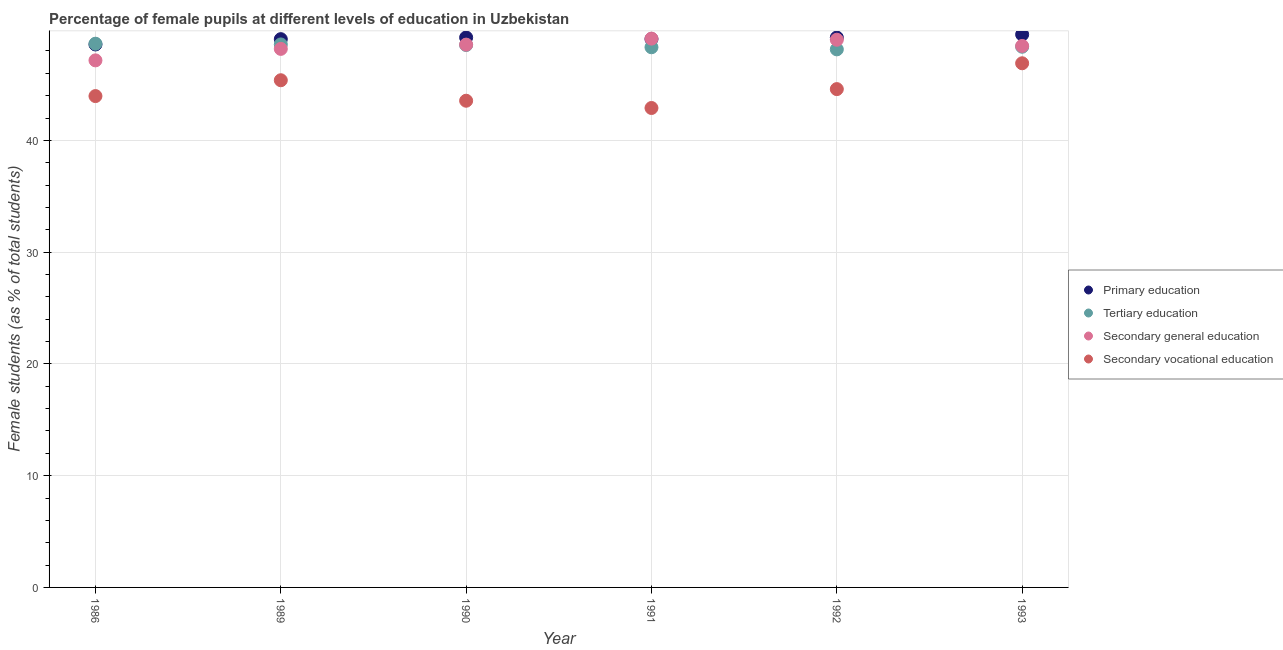What is the percentage of female students in secondary vocational education in 1989?
Provide a succinct answer. 45.38. Across all years, what is the maximum percentage of female students in secondary education?
Keep it short and to the point. 49.1. Across all years, what is the minimum percentage of female students in secondary education?
Provide a short and direct response. 47.16. In which year was the percentage of female students in primary education minimum?
Your answer should be compact. 1986. What is the total percentage of female students in secondary education in the graph?
Ensure brevity in your answer.  290.46. What is the difference between the percentage of female students in secondary education in 1989 and that in 1990?
Ensure brevity in your answer.  -0.38. What is the difference between the percentage of female students in primary education in 1992 and the percentage of female students in secondary education in 1991?
Make the answer very short. 0.1. What is the average percentage of female students in secondary education per year?
Make the answer very short. 48.41. In the year 1990, what is the difference between the percentage of female students in secondary vocational education and percentage of female students in tertiary education?
Ensure brevity in your answer.  -4.99. What is the ratio of the percentage of female students in secondary vocational education in 1989 to that in 1990?
Ensure brevity in your answer.  1.04. Is the percentage of female students in secondary education in 1992 less than that in 1993?
Your response must be concise. No. Is the difference between the percentage of female students in secondary education in 1989 and 1990 greater than the difference between the percentage of female students in secondary vocational education in 1989 and 1990?
Keep it short and to the point. No. What is the difference between the highest and the second highest percentage of female students in secondary vocational education?
Offer a terse response. 1.52. What is the difference between the highest and the lowest percentage of female students in secondary vocational education?
Provide a short and direct response. 4. In how many years, is the percentage of female students in secondary vocational education greater than the average percentage of female students in secondary vocational education taken over all years?
Provide a short and direct response. 3. Is the sum of the percentage of female students in secondary vocational education in 1990 and 1991 greater than the maximum percentage of female students in primary education across all years?
Make the answer very short. Yes. Is it the case that in every year, the sum of the percentage of female students in primary education and percentage of female students in tertiary education is greater than the percentage of female students in secondary education?
Keep it short and to the point. Yes. Is the percentage of female students in tertiary education strictly greater than the percentage of female students in secondary vocational education over the years?
Provide a short and direct response. Yes. Is the percentage of female students in primary education strictly less than the percentage of female students in secondary vocational education over the years?
Give a very brief answer. No. How many dotlines are there?
Provide a short and direct response. 4. Does the graph contain any zero values?
Ensure brevity in your answer.  No. How many legend labels are there?
Make the answer very short. 4. What is the title of the graph?
Provide a short and direct response. Percentage of female pupils at different levels of education in Uzbekistan. What is the label or title of the Y-axis?
Provide a succinct answer. Female students (as % of total students). What is the Female students (as % of total students) in Primary education in 1986?
Provide a succinct answer. 48.58. What is the Female students (as % of total students) in Tertiary education in 1986?
Keep it short and to the point. 48.65. What is the Female students (as % of total students) in Secondary general education in 1986?
Keep it short and to the point. 47.16. What is the Female students (as % of total students) of Secondary vocational education in 1986?
Keep it short and to the point. 43.96. What is the Female students (as % of total students) of Primary education in 1989?
Your answer should be compact. 49.06. What is the Female students (as % of total students) of Tertiary education in 1989?
Your response must be concise. 48.58. What is the Female students (as % of total students) of Secondary general education in 1989?
Provide a succinct answer. 48.18. What is the Female students (as % of total students) in Secondary vocational education in 1989?
Your response must be concise. 45.38. What is the Female students (as % of total students) of Primary education in 1990?
Your response must be concise. 49.2. What is the Female students (as % of total students) of Tertiary education in 1990?
Ensure brevity in your answer.  48.53. What is the Female students (as % of total students) of Secondary general education in 1990?
Make the answer very short. 48.57. What is the Female students (as % of total students) in Secondary vocational education in 1990?
Ensure brevity in your answer.  43.55. What is the Female students (as % of total students) in Primary education in 1991?
Offer a terse response. 49.06. What is the Female students (as % of total students) in Tertiary education in 1991?
Provide a succinct answer. 48.33. What is the Female students (as % of total students) in Secondary general education in 1991?
Offer a very short reply. 49.1. What is the Female students (as % of total students) in Secondary vocational education in 1991?
Provide a succinct answer. 42.9. What is the Female students (as % of total students) of Primary education in 1992?
Keep it short and to the point. 49.2. What is the Female students (as % of total students) of Tertiary education in 1992?
Provide a succinct answer. 48.14. What is the Female students (as % of total students) of Secondary general education in 1992?
Give a very brief answer. 49. What is the Female students (as % of total students) of Secondary vocational education in 1992?
Give a very brief answer. 44.59. What is the Female students (as % of total students) of Primary education in 1993?
Your response must be concise. 49.47. What is the Female students (as % of total students) in Tertiary education in 1993?
Make the answer very short. 48.38. What is the Female students (as % of total students) of Secondary general education in 1993?
Make the answer very short. 48.45. What is the Female students (as % of total students) in Secondary vocational education in 1993?
Give a very brief answer. 46.9. Across all years, what is the maximum Female students (as % of total students) of Primary education?
Provide a short and direct response. 49.47. Across all years, what is the maximum Female students (as % of total students) in Tertiary education?
Your answer should be compact. 48.65. Across all years, what is the maximum Female students (as % of total students) in Secondary general education?
Offer a very short reply. 49.1. Across all years, what is the maximum Female students (as % of total students) of Secondary vocational education?
Keep it short and to the point. 46.9. Across all years, what is the minimum Female students (as % of total students) in Primary education?
Provide a succinct answer. 48.58. Across all years, what is the minimum Female students (as % of total students) in Tertiary education?
Offer a very short reply. 48.14. Across all years, what is the minimum Female students (as % of total students) in Secondary general education?
Keep it short and to the point. 47.16. Across all years, what is the minimum Female students (as % of total students) of Secondary vocational education?
Keep it short and to the point. 42.9. What is the total Female students (as % of total students) of Primary education in the graph?
Make the answer very short. 294.57. What is the total Female students (as % of total students) in Tertiary education in the graph?
Offer a very short reply. 290.61. What is the total Female students (as % of total students) of Secondary general education in the graph?
Your response must be concise. 290.46. What is the total Female students (as % of total students) of Secondary vocational education in the graph?
Your answer should be very brief. 267.27. What is the difference between the Female students (as % of total students) in Primary education in 1986 and that in 1989?
Offer a terse response. -0.48. What is the difference between the Female students (as % of total students) of Tertiary education in 1986 and that in 1989?
Keep it short and to the point. 0.06. What is the difference between the Female students (as % of total students) of Secondary general education in 1986 and that in 1989?
Offer a very short reply. -1.03. What is the difference between the Female students (as % of total students) in Secondary vocational education in 1986 and that in 1989?
Ensure brevity in your answer.  -1.42. What is the difference between the Female students (as % of total students) in Primary education in 1986 and that in 1990?
Ensure brevity in your answer.  -0.62. What is the difference between the Female students (as % of total students) of Tertiary education in 1986 and that in 1990?
Offer a very short reply. 0.11. What is the difference between the Female students (as % of total students) in Secondary general education in 1986 and that in 1990?
Provide a short and direct response. -1.41. What is the difference between the Female students (as % of total students) of Secondary vocational education in 1986 and that in 1990?
Offer a terse response. 0.42. What is the difference between the Female students (as % of total students) of Primary education in 1986 and that in 1991?
Your answer should be compact. -0.48. What is the difference between the Female students (as % of total students) in Tertiary education in 1986 and that in 1991?
Provide a short and direct response. 0.32. What is the difference between the Female students (as % of total students) in Secondary general education in 1986 and that in 1991?
Ensure brevity in your answer.  -1.95. What is the difference between the Female students (as % of total students) of Secondary vocational education in 1986 and that in 1991?
Your answer should be very brief. 1.07. What is the difference between the Female students (as % of total students) in Primary education in 1986 and that in 1992?
Make the answer very short. -0.62. What is the difference between the Female students (as % of total students) of Tertiary education in 1986 and that in 1992?
Make the answer very short. 0.51. What is the difference between the Female students (as % of total students) of Secondary general education in 1986 and that in 1992?
Provide a short and direct response. -1.85. What is the difference between the Female students (as % of total students) in Secondary vocational education in 1986 and that in 1992?
Provide a short and direct response. -0.62. What is the difference between the Female students (as % of total students) in Primary education in 1986 and that in 1993?
Offer a very short reply. -0.89. What is the difference between the Female students (as % of total students) of Tertiary education in 1986 and that in 1993?
Your answer should be very brief. 0.27. What is the difference between the Female students (as % of total students) in Secondary general education in 1986 and that in 1993?
Ensure brevity in your answer.  -1.29. What is the difference between the Female students (as % of total students) in Secondary vocational education in 1986 and that in 1993?
Provide a succinct answer. -2.94. What is the difference between the Female students (as % of total students) of Primary education in 1989 and that in 1990?
Your answer should be very brief. -0.15. What is the difference between the Female students (as % of total students) of Tertiary education in 1989 and that in 1990?
Your response must be concise. 0.05. What is the difference between the Female students (as % of total students) in Secondary general education in 1989 and that in 1990?
Ensure brevity in your answer.  -0.38. What is the difference between the Female students (as % of total students) in Secondary vocational education in 1989 and that in 1990?
Your answer should be compact. 1.83. What is the difference between the Female students (as % of total students) of Primary education in 1989 and that in 1991?
Offer a terse response. -0.01. What is the difference between the Female students (as % of total students) of Tertiary education in 1989 and that in 1991?
Make the answer very short. 0.25. What is the difference between the Female students (as % of total students) of Secondary general education in 1989 and that in 1991?
Provide a succinct answer. -0.92. What is the difference between the Female students (as % of total students) of Secondary vocational education in 1989 and that in 1991?
Give a very brief answer. 2.48. What is the difference between the Female students (as % of total students) in Primary education in 1989 and that in 1992?
Make the answer very short. -0.14. What is the difference between the Female students (as % of total students) of Tertiary education in 1989 and that in 1992?
Make the answer very short. 0.44. What is the difference between the Female students (as % of total students) in Secondary general education in 1989 and that in 1992?
Your answer should be compact. -0.82. What is the difference between the Female students (as % of total students) in Secondary vocational education in 1989 and that in 1992?
Give a very brief answer. 0.79. What is the difference between the Female students (as % of total students) in Primary education in 1989 and that in 1993?
Give a very brief answer. -0.42. What is the difference between the Female students (as % of total students) in Tertiary education in 1989 and that in 1993?
Your response must be concise. 0.2. What is the difference between the Female students (as % of total students) in Secondary general education in 1989 and that in 1993?
Your response must be concise. -0.27. What is the difference between the Female students (as % of total students) in Secondary vocational education in 1989 and that in 1993?
Provide a succinct answer. -1.52. What is the difference between the Female students (as % of total students) in Primary education in 1990 and that in 1991?
Your answer should be very brief. 0.14. What is the difference between the Female students (as % of total students) of Tertiary education in 1990 and that in 1991?
Give a very brief answer. 0.2. What is the difference between the Female students (as % of total students) of Secondary general education in 1990 and that in 1991?
Your answer should be very brief. -0.54. What is the difference between the Female students (as % of total students) of Secondary vocational education in 1990 and that in 1991?
Offer a very short reply. 0.65. What is the difference between the Female students (as % of total students) in Primary education in 1990 and that in 1992?
Offer a very short reply. 0. What is the difference between the Female students (as % of total students) in Tertiary education in 1990 and that in 1992?
Make the answer very short. 0.39. What is the difference between the Female students (as % of total students) in Secondary general education in 1990 and that in 1992?
Provide a short and direct response. -0.44. What is the difference between the Female students (as % of total students) in Secondary vocational education in 1990 and that in 1992?
Your answer should be very brief. -1.04. What is the difference between the Female students (as % of total students) in Primary education in 1990 and that in 1993?
Offer a very short reply. -0.27. What is the difference between the Female students (as % of total students) in Tertiary education in 1990 and that in 1993?
Ensure brevity in your answer.  0.15. What is the difference between the Female students (as % of total students) in Secondary general education in 1990 and that in 1993?
Provide a succinct answer. 0.12. What is the difference between the Female students (as % of total students) of Secondary vocational education in 1990 and that in 1993?
Make the answer very short. -3.35. What is the difference between the Female students (as % of total students) in Primary education in 1991 and that in 1992?
Offer a terse response. -0.13. What is the difference between the Female students (as % of total students) in Tertiary education in 1991 and that in 1992?
Your response must be concise. 0.19. What is the difference between the Female students (as % of total students) in Secondary general education in 1991 and that in 1992?
Provide a succinct answer. 0.1. What is the difference between the Female students (as % of total students) in Secondary vocational education in 1991 and that in 1992?
Ensure brevity in your answer.  -1.69. What is the difference between the Female students (as % of total students) in Primary education in 1991 and that in 1993?
Ensure brevity in your answer.  -0.41. What is the difference between the Female students (as % of total students) in Tertiary education in 1991 and that in 1993?
Provide a succinct answer. -0.05. What is the difference between the Female students (as % of total students) in Secondary general education in 1991 and that in 1993?
Make the answer very short. 0.65. What is the difference between the Female students (as % of total students) in Secondary vocational education in 1991 and that in 1993?
Offer a terse response. -4. What is the difference between the Female students (as % of total students) of Primary education in 1992 and that in 1993?
Give a very brief answer. -0.27. What is the difference between the Female students (as % of total students) in Tertiary education in 1992 and that in 1993?
Keep it short and to the point. -0.24. What is the difference between the Female students (as % of total students) of Secondary general education in 1992 and that in 1993?
Your answer should be very brief. 0.55. What is the difference between the Female students (as % of total students) of Secondary vocational education in 1992 and that in 1993?
Give a very brief answer. -2.31. What is the difference between the Female students (as % of total students) in Primary education in 1986 and the Female students (as % of total students) in Tertiary education in 1989?
Your response must be concise. -0. What is the difference between the Female students (as % of total students) in Primary education in 1986 and the Female students (as % of total students) in Secondary general education in 1989?
Provide a short and direct response. 0.39. What is the difference between the Female students (as % of total students) in Primary education in 1986 and the Female students (as % of total students) in Secondary vocational education in 1989?
Your response must be concise. 3.2. What is the difference between the Female students (as % of total students) of Tertiary education in 1986 and the Female students (as % of total students) of Secondary general education in 1989?
Your answer should be compact. 0.46. What is the difference between the Female students (as % of total students) of Tertiary education in 1986 and the Female students (as % of total students) of Secondary vocational education in 1989?
Offer a terse response. 3.27. What is the difference between the Female students (as % of total students) of Secondary general education in 1986 and the Female students (as % of total students) of Secondary vocational education in 1989?
Give a very brief answer. 1.78. What is the difference between the Female students (as % of total students) in Primary education in 1986 and the Female students (as % of total students) in Tertiary education in 1990?
Give a very brief answer. 0.05. What is the difference between the Female students (as % of total students) in Primary education in 1986 and the Female students (as % of total students) in Secondary general education in 1990?
Your answer should be compact. 0.01. What is the difference between the Female students (as % of total students) in Primary education in 1986 and the Female students (as % of total students) in Secondary vocational education in 1990?
Ensure brevity in your answer.  5.03. What is the difference between the Female students (as % of total students) in Tertiary education in 1986 and the Female students (as % of total students) in Secondary general education in 1990?
Keep it short and to the point. 0.08. What is the difference between the Female students (as % of total students) of Tertiary education in 1986 and the Female students (as % of total students) of Secondary vocational education in 1990?
Make the answer very short. 5.1. What is the difference between the Female students (as % of total students) in Secondary general education in 1986 and the Female students (as % of total students) in Secondary vocational education in 1990?
Provide a short and direct response. 3.61. What is the difference between the Female students (as % of total students) in Primary education in 1986 and the Female students (as % of total students) in Tertiary education in 1991?
Your answer should be compact. 0.25. What is the difference between the Female students (as % of total students) of Primary education in 1986 and the Female students (as % of total students) of Secondary general education in 1991?
Offer a terse response. -0.52. What is the difference between the Female students (as % of total students) in Primary education in 1986 and the Female students (as % of total students) in Secondary vocational education in 1991?
Give a very brief answer. 5.68. What is the difference between the Female students (as % of total students) of Tertiary education in 1986 and the Female students (as % of total students) of Secondary general education in 1991?
Offer a very short reply. -0.46. What is the difference between the Female students (as % of total students) of Tertiary education in 1986 and the Female students (as % of total students) of Secondary vocational education in 1991?
Provide a succinct answer. 5.75. What is the difference between the Female students (as % of total students) in Secondary general education in 1986 and the Female students (as % of total students) in Secondary vocational education in 1991?
Offer a terse response. 4.26. What is the difference between the Female students (as % of total students) of Primary education in 1986 and the Female students (as % of total students) of Tertiary education in 1992?
Your response must be concise. 0.44. What is the difference between the Female students (as % of total students) of Primary education in 1986 and the Female students (as % of total students) of Secondary general education in 1992?
Your response must be concise. -0.42. What is the difference between the Female students (as % of total students) of Primary education in 1986 and the Female students (as % of total students) of Secondary vocational education in 1992?
Give a very brief answer. 3.99. What is the difference between the Female students (as % of total students) in Tertiary education in 1986 and the Female students (as % of total students) in Secondary general education in 1992?
Your answer should be very brief. -0.35. What is the difference between the Female students (as % of total students) in Tertiary education in 1986 and the Female students (as % of total students) in Secondary vocational education in 1992?
Your answer should be very brief. 4.06. What is the difference between the Female students (as % of total students) of Secondary general education in 1986 and the Female students (as % of total students) of Secondary vocational education in 1992?
Keep it short and to the point. 2.57. What is the difference between the Female students (as % of total students) in Primary education in 1986 and the Female students (as % of total students) in Tertiary education in 1993?
Provide a succinct answer. 0.2. What is the difference between the Female students (as % of total students) of Primary education in 1986 and the Female students (as % of total students) of Secondary general education in 1993?
Provide a succinct answer. 0.13. What is the difference between the Female students (as % of total students) in Primary education in 1986 and the Female students (as % of total students) in Secondary vocational education in 1993?
Your answer should be compact. 1.68. What is the difference between the Female students (as % of total students) of Tertiary education in 1986 and the Female students (as % of total students) of Secondary general education in 1993?
Offer a very short reply. 0.2. What is the difference between the Female students (as % of total students) in Tertiary education in 1986 and the Female students (as % of total students) in Secondary vocational education in 1993?
Give a very brief answer. 1.75. What is the difference between the Female students (as % of total students) of Secondary general education in 1986 and the Female students (as % of total students) of Secondary vocational education in 1993?
Offer a very short reply. 0.26. What is the difference between the Female students (as % of total students) of Primary education in 1989 and the Female students (as % of total students) of Tertiary education in 1990?
Provide a short and direct response. 0.52. What is the difference between the Female students (as % of total students) in Primary education in 1989 and the Female students (as % of total students) in Secondary general education in 1990?
Ensure brevity in your answer.  0.49. What is the difference between the Female students (as % of total students) of Primary education in 1989 and the Female students (as % of total students) of Secondary vocational education in 1990?
Your response must be concise. 5.51. What is the difference between the Female students (as % of total students) of Tertiary education in 1989 and the Female students (as % of total students) of Secondary general education in 1990?
Your answer should be very brief. 0.02. What is the difference between the Female students (as % of total students) of Tertiary education in 1989 and the Female students (as % of total students) of Secondary vocational education in 1990?
Your response must be concise. 5.04. What is the difference between the Female students (as % of total students) of Secondary general education in 1989 and the Female students (as % of total students) of Secondary vocational education in 1990?
Offer a terse response. 4.64. What is the difference between the Female students (as % of total students) of Primary education in 1989 and the Female students (as % of total students) of Tertiary education in 1991?
Give a very brief answer. 0.73. What is the difference between the Female students (as % of total students) in Primary education in 1989 and the Female students (as % of total students) in Secondary general education in 1991?
Offer a terse response. -0.05. What is the difference between the Female students (as % of total students) in Primary education in 1989 and the Female students (as % of total students) in Secondary vocational education in 1991?
Make the answer very short. 6.16. What is the difference between the Female students (as % of total students) of Tertiary education in 1989 and the Female students (as % of total students) of Secondary general education in 1991?
Make the answer very short. -0.52. What is the difference between the Female students (as % of total students) in Tertiary education in 1989 and the Female students (as % of total students) in Secondary vocational education in 1991?
Offer a terse response. 5.69. What is the difference between the Female students (as % of total students) of Secondary general education in 1989 and the Female students (as % of total students) of Secondary vocational education in 1991?
Give a very brief answer. 5.29. What is the difference between the Female students (as % of total students) of Primary education in 1989 and the Female students (as % of total students) of Tertiary education in 1992?
Keep it short and to the point. 0.91. What is the difference between the Female students (as % of total students) of Primary education in 1989 and the Female students (as % of total students) of Secondary general education in 1992?
Keep it short and to the point. 0.05. What is the difference between the Female students (as % of total students) of Primary education in 1989 and the Female students (as % of total students) of Secondary vocational education in 1992?
Provide a succinct answer. 4.47. What is the difference between the Female students (as % of total students) of Tertiary education in 1989 and the Female students (as % of total students) of Secondary general education in 1992?
Your answer should be very brief. -0.42. What is the difference between the Female students (as % of total students) in Tertiary education in 1989 and the Female students (as % of total students) in Secondary vocational education in 1992?
Your response must be concise. 4. What is the difference between the Female students (as % of total students) in Secondary general education in 1989 and the Female students (as % of total students) in Secondary vocational education in 1992?
Offer a very short reply. 3.6. What is the difference between the Female students (as % of total students) of Primary education in 1989 and the Female students (as % of total students) of Tertiary education in 1993?
Provide a succinct answer. 0.68. What is the difference between the Female students (as % of total students) of Primary education in 1989 and the Female students (as % of total students) of Secondary general education in 1993?
Your response must be concise. 0.61. What is the difference between the Female students (as % of total students) in Primary education in 1989 and the Female students (as % of total students) in Secondary vocational education in 1993?
Give a very brief answer. 2.16. What is the difference between the Female students (as % of total students) in Tertiary education in 1989 and the Female students (as % of total students) in Secondary general education in 1993?
Give a very brief answer. 0.13. What is the difference between the Female students (as % of total students) of Tertiary education in 1989 and the Female students (as % of total students) of Secondary vocational education in 1993?
Ensure brevity in your answer.  1.69. What is the difference between the Female students (as % of total students) of Secondary general education in 1989 and the Female students (as % of total students) of Secondary vocational education in 1993?
Your answer should be very brief. 1.29. What is the difference between the Female students (as % of total students) in Primary education in 1990 and the Female students (as % of total students) in Tertiary education in 1991?
Offer a terse response. 0.87. What is the difference between the Female students (as % of total students) in Primary education in 1990 and the Female students (as % of total students) in Secondary general education in 1991?
Provide a short and direct response. 0.1. What is the difference between the Female students (as % of total students) of Primary education in 1990 and the Female students (as % of total students) of Secondary vocational education in 1991?
Your response must be concise. 6.31. What is the difference between the Female students (as % of total students) of Tertiary education in 1990 and the Female students (as % of total students) of Secondary general education in 1991?
Your response must be concise. -0.57. What is the difference between the Female students (as % of total students) in Tertiary education in 1990 and the Female students (as % of total students) in Secondary vocational education in 1991?
Keep it short and to the point. 5.64. What is the difference between the Female students (as % of total students) in Secondary general education in 1990 and the Female students (as % of total students) in Secondary vocational education in 1991?
Offer a very short reply. 5.67. What is the difference between the Female students (as % of total students) in Primary education in 1990 and the Female students (as % of total students) in Tertiary education in 1992?
Your response must be concise. 1.06. What is the difference between the Female students (as % of total students) in Primary education in 1990 and the Female students (as % of total students) in Secondary general education in 1992?
Give a very brief answer. 0.2. What is the difference between the Female students (as % of total students) of Primary education in 1990 and the Female students (as % of total students) of Secondary vocational education in 1992?
Provide a succinct answer. 4.62. What is the difference between the Female students (as % of total students) in Tertiary education in 1990 and the Female students (as % of total students) in Secondary general education in 1992?
Offer a very short reply. -0.47. What is the difference between the Female students (as % of total students) in Tertiary education in 1990 and the Female students (as % of total students) in Secondary vocational education in 1992?
Keep it short and to the point. 3.95. What is the difference between the Female students (as % of total students) of Secondary general education in 1990 and the Female students (as % of total students) of Secondary vocational education in 1992?
Provide a short and direct response. 3.98. What is the difference between the Female students (as % of total students) in Primary education in 1990 and the Female students (as % of total students) in Tertiary education in 1993?
Ensure brevity in your answer.  0.82. What is the difference between the Female students (as % of total students) of Primary education in 1990 and the Female students (as % of total students) of Secondary general education in 1993?
Provide a succinct answer. 0.75. What is the difference between the Female students (as % of total students) in Primary education in 1990 and the Female students (as % of total students) in Secondary vocational education in 1993?
Your response must be concise. 2.31. What is the difference between the Female students (as % of total students) in Tertiary education in 1990 and the Female students (as % of total students) in Secondary general education in 1993?
Offer a very short reply. 0.08. What is the difference between the Female students (as % of total students) in Tertiary education in 1990 and the Female students (as % of total students) in Secondary vocational education in 1993?
Provide a succinct answer. 1.64. What is the difference between the Female students (as % of total students) in Secondary general education in 1990 and the Female students (as % of total students) in Secondary vocational education in 1993?
Offer a terse response. 1.67. What is the difference between the Female students (as % of total students) of Primary education in 1991 and the Female students (as % of total students) of Tertiary education in 1992?
Offer a very short reply. 0.92. What is the difference between the Female students (as % of total students) of Primary education in 1991 and the Female students (as % of total students) of Secondary general education in 1992?
Your response must be concise. 0.06. What is the difference between the Female students (as % of total students) of Primary education in 1991 and the Female students (as % of total students) of Secondary vocational education in 1992?
Your answer should be compact. 4.48. What is the difference between the Female students (as % of total students) in Tertiary education in 1991 and the Female students (as % of total students) in Secondary general education in 1992?
Your response must be concise. -0.67. What is the difference between the Female students (as % of total students) of Tertiary education in 1991 and the Female students (as % of total students) of Secondary vocational education in 1992?
Offer a very short reply. 3.74. What is the difference between the Female students (as % of total students) of Secondary general education in 1991 and the Female students (as % of total students) of Secondary vocational education in 1992?
Your answer should be very brief. 4.52. What is the difference between the Female students (as % of total students) of Primary education in 1991 and the Female students (as % of total students) of Tertiary education in 1993?
Your response must be concise. 0.69. What is the difference between the Female students (as % of total students) of Primary education in 1991 and the Female students (as % of total students) of Secondary general education in 1993?
Offer a terse response. 0.61. What is the difference between the Female students (as % of total students) of Primary education in 1991 and the Female students (as % of total students) of Secondary vocational education in 1993?
Provide a short and direct response. 2.17. What is the difference between the Female students (as % of total students) in Tertiary education in 1991 and the Female students (as % of total students) in Secondary general education in 1993?
Your response must be concise. -0.12. What is the difference between the Female students (as % of total students) in Tertiary education in 1991 and the Female students (as % of total students) in Secondary vocational education in 1993?
Provide a succinct answer. 1.43. What is the difference between the Female students (as % of total students) in Secondary general education in 1991 and the Female students (as % of total students) in Secondary vocational education in 1993?
Offer a terse response. 2.21. What is the difference between the Female students (as % of total students) in Primary education in 1992 and the Female students (as % of total students) in Tertiary education in 1993?
Your answer should be very brief. 0.82. What is the difference between the Female students (as % of total students) of Primary education in 1992 and the Female students (as % of total students) of Secondary general education in 1993?
Provide a succinct answer. 0.75. What is the difference between the Female students (as % of total students) of Primary education in 1992 and the Female students (as % of total students) of Secondary vocational education in 1993?
Your answer should be very brief. 2.3. What is the difference between the Female students (as % of total students) of Tertiary education in 1992 and the Female students (as % of total students) of Secondary general education in 1993?
Offer a very short reply. -0.31. What is the difference between the Female students (as % of total students) in Tertiary education in 1992 and the Female students (as % of total students) in Secondary vocational education in 1993?
Ensure brevity in your answer.  1.24. What is the difference between the Female students (as % of total students) in Secondary general education in 1992 and the Female students (as % of total students) in Secondary vocational education in 1993?
Keep it short and to the point. 2.1. What is the average Female students (as % of total students) of Primary education per year?
Provide a short and direct response. 49.1. What is the average Female students (as % of total students) of Tertiary education per year?
Ensure brevity in your answer.  48.44. What is the average Female students (as % of total students) of Secondary general education per year?
Your answer should be very brief. 48.41. What is the average Female students (as % of total students) of Secondary vocational education per year?
Offer a very short reply. 44.54. In the year 1986, what is the difference between the Female students (as % of total students) in Primary education and Female students (as % of total students) in Tertiary education?
Ensure brevity in your answer.  -0.07. In the year 1986, what is the difference between the Female students (as % of total students) in Primary education and Female students (as % of total students) in Secondary general education?
Provide a short and direct response. 1.42. In the year 1986, what is the difference between the Female students (as % of total students) in Primary education and Female students (as % of total students) in Secondary vocational education?
Provide a short and direct response. 4.62. In the year 1986, what is the difference between the Female students (as % of total students) in Tertiary education and Female students (as % of total students) in Secondary general education?
Give a very brief answer. 1.49. In the year 1986, what is the difference between the Female students (as % of total students) in Tertiary education and Female students (as % of total students) in Secondary vocational education?
Offer a very short reply. 4.68. In the year 1986, what is the difference between the Female students (as % of total students) of Secondary general education and Female students (as % of total students) of Secondary vocational education?
Make the answer very short. 3.19. In the year 1989, what is the difference between the Female students (as % of total students) of Primary education and Female students (as % of total students) of Tertiary education?
Ensure brevity in your answer.  0.47. In the year 1989, what is the difference between the Female students (as % of total students) of Primary education and Female students (as % of total students) of Secondary general education?
Provide a short and direct response. 0.87. In the year 1989, what is the difference between the Female students (as % of total students) of Primary education and Female students (as % of total students) of Secondary vocational education?
Make the answer very short. 3.68. In the year 1989, what is the difference between the Female students (as % of total students) in Tertiary education and Female students (as % of total students) in Secondary general education?
Provide a short and direct response. 0.4. In the year 1989, what is the difference between the Female students (as % of total students) of Tertiary education and Female students (as % of total students) of Secondary vocational education?
Ensure brevity in your answer.  3.2. In the year 1989, what is the difference between the Female students (as % of total students) in Secondary general education and Female students (as % of total students) in Secondary vocational education?
Your answer should be very brief. 2.81. In the year 1990, what is the difference between the Female students (as % of total students) of Primary education and Female students (as % of total students) of Tertiary education?
Keep it short and to the point. 0.67. In the year 1990, what is the difference between the Female students (as % of total students) of Primary education and Female students (as % of total students) of Secondary general education?
Keep it short and to the point. 0.64. In the year 1990, what is the difference between the Female students (as % of total students) of Primary education and Female students (as % of total students) of Secondary vocational education?
Offer a very short reply. 5.66. In the year 1990, what is the difference between the Female students (as % of total students) in Tertiary education and Female students (as % of total students) in Secondary general education?
Provide a short and direct response. -0.03. In the year 1990, what is the difference between the Female students (as % of total students) of Tertiary education and Female students (as % of total students) of Secondary vocational education?
Ensure brevity in your answer.  4.99. In the year 1990, what is the difference between the Female students (as % of total students) of Secondary general education and Female students (as % of total students) of Secondary vocational education?
Provide a short and direct response. 5.02. In the year 1991, what is the difference between the Female students (as % of total students) of Primary education and Female students (as % of total students) of Tertiary education?
Your response must be concise. 0.73. In the year 1991, what is the difference between the Female students (as % of total students) in Primary education and Female students (as % of total students) in Secondary general education?
Keep it short and to the point. -0.04. In the year 1991, what is the difference between the Female students (as % of total students) of Primary education and Female students (as % of total students) of Secondary vocational education?
Offer a terse response. 6.17. In the year 1991, what is the difference between the Female students (as % of total students) in Tertiary education and Female students (as % of total students) in Secondary general education?
Ensure brevity in your answer.  -0.77. In the year 1991, what is the difference between the Female students (as % of total students) of Tertiary education and Female students (as % of total students) of Secondary vocational education?
Offer a terse response. 5.43. In the year 1991, what is the difference between the Female students (as % of total students) of Secondary general education and Female students (as % of total students) of Secondary vocational education?
Provide a succinct answer. 6.21. In the year 1992, what is the difference between the Female students (as % of total students) in Primary education and Female students (as % of total students) in Tertiary education?
Provide a succinct answer. 1.06. In the year 1992, what is the difference between the Female students (as % of total students) of Primary education and Female students (as % of total students) of Secondary general education?
Ensure brevity in your answer.  0.2. In the year 1992, what is the difference between the Female students (as % of total students) of Primary education and Female students (as % of total students) of Secondary vocational education?
Make the answer very short. 4.61. In the year 1992, what is the difference between the Female students (as % of total students) in Tertiary education and Female students (as % of total students) in Secondary general education?
Provide a short and direct response. -0.86. In the year 1992, what is the difference between the Female students (as % of total students) of Tertiary education and Female students (as % of total students) of Secondary vocational education?
Offer a very short reply. 3.56. In the year 1992, what is the difference between the Female students (as % of total students) of Secondary general education and Female students (as % of total students) of Secondary vocational education?
Provide a short and direct response. 4.42. In the year 1993, what is the difference between the Female students (as % of total students) of Primary education and Female students (as % of total students) of Tertiary education?
Offer a terse response. 1.09. In the year 1993, what is the difference between the Female students (as % of total students) in Primary education and Female students (as % of total students) in Secondary vocational education?
Make the answer very short. 2.57. In the year 1993, what is the difference between the Female students (as % of total students) of Tertiary education and Female students (as % of total students) of Secondary general education?
Make the answer very short. -0.07. In the year 1993, what is the difference between the Female students (as % of total students) of Tertiary education and Female students (as % of total students) of Secondary vocational education?
Ensure brevity in your answer.  1.48. In the year 1993, what is the difference between the Female students (as % of total students) of Secondary general education and Female students (as % of total students) of Secondary vocational education?
Ensure brevity in your answer.  1.55. What is the ratio of the Female students (as % of total students) in Primary education in 1986 to that in 1989?
Offer a terse response. 0.99. What is the ratio of the Female students (as % of total students) in Tertiary education in 1986 to that in 1989?
Your answer should be very brief. 1. What is the ratio of the Female students (as % of total students) of Secondary general education in 1986 to that in 1989?
Your answer should be very brief. 0.98. What is the ratio of the Female students (as % of total students) of Secondary vocational education in 1986 to that in 1989?
Offer a very short reply. 0.97. What is the ratio of the Female students (as % of total students) of Primary education in 1986 to that in 1990?
Your answer should be compact. 0.99. What is the ratio of the Female students (as % of total students) of Tertiary education in 1986 to that in 1990?
Your response must be concise. 1. What is the ratio of the Female students (as % of total students) in Secondary general education in 1986 to that in 1990?
Ensure brevity in your answer.  0.97. What is the ratio of the Female students (as % of total students) in Secondary vocational education in 1986 to that in 1990?
Keep it short and to the point. 1.01. What is the ratio of the Female students (as % of total students) of Tertiary education in 1986 to that in 1991?
Keep it short and to the point. 1.01. What is the ratio of the Female students (as % of total students) of Secondary general education in 1986 to that in 1991?
Offer a terse response. 0.96. What is the ratio of the Female students (as % of total students) in Secondary vocational education in 1986 to that in 1991?
Ensure brevity in your answer.  1.02. What is the ratio of the Female students (as % of total students) in Primary education in 1986 to that in 1992?
Offer a terse response. 0.99. What is the ratio of the Female students (as % of total students) in Tertiary education in 1986 to that in 1992?
Provide a succinct answer. 1.01. What is the ratio of the Female students (as % of total students) of Secondary general education in 1986 to that in 1992?
Your answer should be very brief. 0.96. What is the ratio of the Female students (as % of total students) of Secondary vocational education in 1986 to that in 1992?
Provide a short and direct response. 0.99. What is the ratio of the Female students (as % of total students) in Primary education in 1986 to that in 1993?
Offer a terse response. 0.98. What is the ratio of the Female students (as % of total students) in Tertiary education in 1986 to that in 1993?
Offer a terse response. 1.01. What is the ratio of the Female students (as % of total students) of Secondary general education in 1986 to that in 1993?
Keep it short and to the point. 0.97. What is the ratio of the Female students (as % of total students) in Secondary vocational education in 1986 to that in 1993?
Keep it short and to the point. 0.94. What is the ratio of the Female students (as % of total students) in Tertiary education in 1989 to that in 1990?
Your answer should be compact. 1. What is the ratio of the Female students (as % of total students) in Secondary vocational education in 1989 to that in 1990?
Offer a very short reply. 1.04. What is the ratio of the Female students (as % of total students) in Secondary general education in 1989 to that in 1991?
Your response must be concise. 0.98. What is the ratio of the Female students (as % of total students) in Secondary vocational education in 1989 to that in 1991?
Ensure brevity in your answer.  1.06. What is the ratio of the Female students (as % of total students) of Primary education in 1989 to that in 1992?
Provide a short and direct response. 1. What is the ratio of the Female students (as % of total students) of Tertiary education in 1989 to that in 1992?
Offer a terse response. 1.01. What is the ratio of the Female students (as % of total students) in Secondary general education in 1989 to that in 1992?
Provide a succinct answer. 0.98. What is the ratio of the Female students (as % of total students) in Secondary vocational education in 1989 to that in 1992?
Your answer should be compact. 1.02. What is the ratio of the Female students (as % of total students) of Primary education in 1989 to that in 1993?
Give a very brief answer. 0.99. What is the ratio of the Female students (as % of total students) in Tertiary education in 1989 to that in 1993?
Ensure brevity in your answer.  1. What is the ratio of the Female students (as % of total students) in Secondary general education in 1989 to that in 1993?
Provide a succinct answer. 0.99. What is the ratio of the Female students (as % of total students) in Secondary vocational education in 1989 to that in 1993?
Ensure brevity in your answer.  0.97. What is the ratio of the Female students (as % of total students) in Secondary general education in 1990 to that in 1991?
Keep it short and to the point. 0.99. What is the ratio of the Female students (as % of total students) in Secondary vocational education in 1990 to that in 1991?
Make the answer very short. 1.02. What is the ratio of the Female students (as % of total students) of Tertiary education in 1990 to that in 1992?
Ensure brevity in your answer.  1.01. What is the ratio of the Female students (as % of total students) in Secondary general education in 1990 to that in 1992?
Your answer should be compact. 0.99. What is the ratio of the Female students (as % of total students) of Secondary vocational education in 1990 to that in 1992?
Ensure brevity in your answer.  0.98. What is the ratio of the Female students (as % of total students) in Secondary vocational education in 1990 to that in 1993?
Offer a very short reply. 0.93. What is the ratio of the Female students (as % of total students) of Tertiary education in 1991 to that in 1992?
Provide a short and direct response. 1. What is the ratio of the Female students (as % of total students) in Secondary vocational education in 1991 to that in 1992?
Provide a succinct answer. 0.96. What is the ratio of the Female students (as % of total students) of Primary education in 1991 to that in 1993?
Offer a very short reply. 0.99. What is the ratio of the Female students (as % of total students) in Tertiary education in 1991 to that in 1993?
Your answer should be compact. 1. What is the ratio of the Female students (as % of total students) of Secondary general education in 1991 to that in 1993?
Your answer should be very brief. 1.01. What is the ratio of the Female students (as % of total students) in Secondary vocational education in 1991 to that in 1993?
Ensure brevity in your answer.  0.91. What is the ratio of the Female students (as % of total students) in Primary education in 1992 to that in 1993?
Offer a very short reply. 0.99. What is the ratio of the Female students (as % of total students) in Tertiary education in 1992 to that in 1993?
Offer a terse response. 1. What is the ratio of the Female students (as % of total students) of Secondary general education in 1992 to that in 1993?
Provide a short and direct response. 1.01. What is the ratio of the Female students (as % of total students) of Secondary vocational education in 1992 to that in 1993?
Keep it short and to the point. 0.95. What is the difference between the highest and the second highest Female students (as % of total students) in Primary education?
Offer a terse response. 0.27. What is the difference between the highest and the second highest Female students (as % of total students) in Tertiary education?
Provide a short and direct response. 0.06. What is the difference between the highest and the second highest Female students (as % of total students) in Secondary general education?
Offer a terse response. 0.1. What is the difference between the highest and the second highest Female students (as % of total students) in Secondary vocational education?
Offer a very short reply. 1.52. What is the difference between the highest and the lowest Female students (as % of total students) of Primary education?
Your response must be concise. 0.89. What is the difference between the highest and the lowest Female students (as % of total students) in Tertiary education?
Offer a terse response. 0.51. What is the difference between the highest and the lowest Female students (as % of total students) of Secondary general education?
Make the answer very short. 1.95. What is the difference between the highest and the lowest Female students (as % of total students) in Secondary vocational education?
Ensure brevity in your answer.  4. 